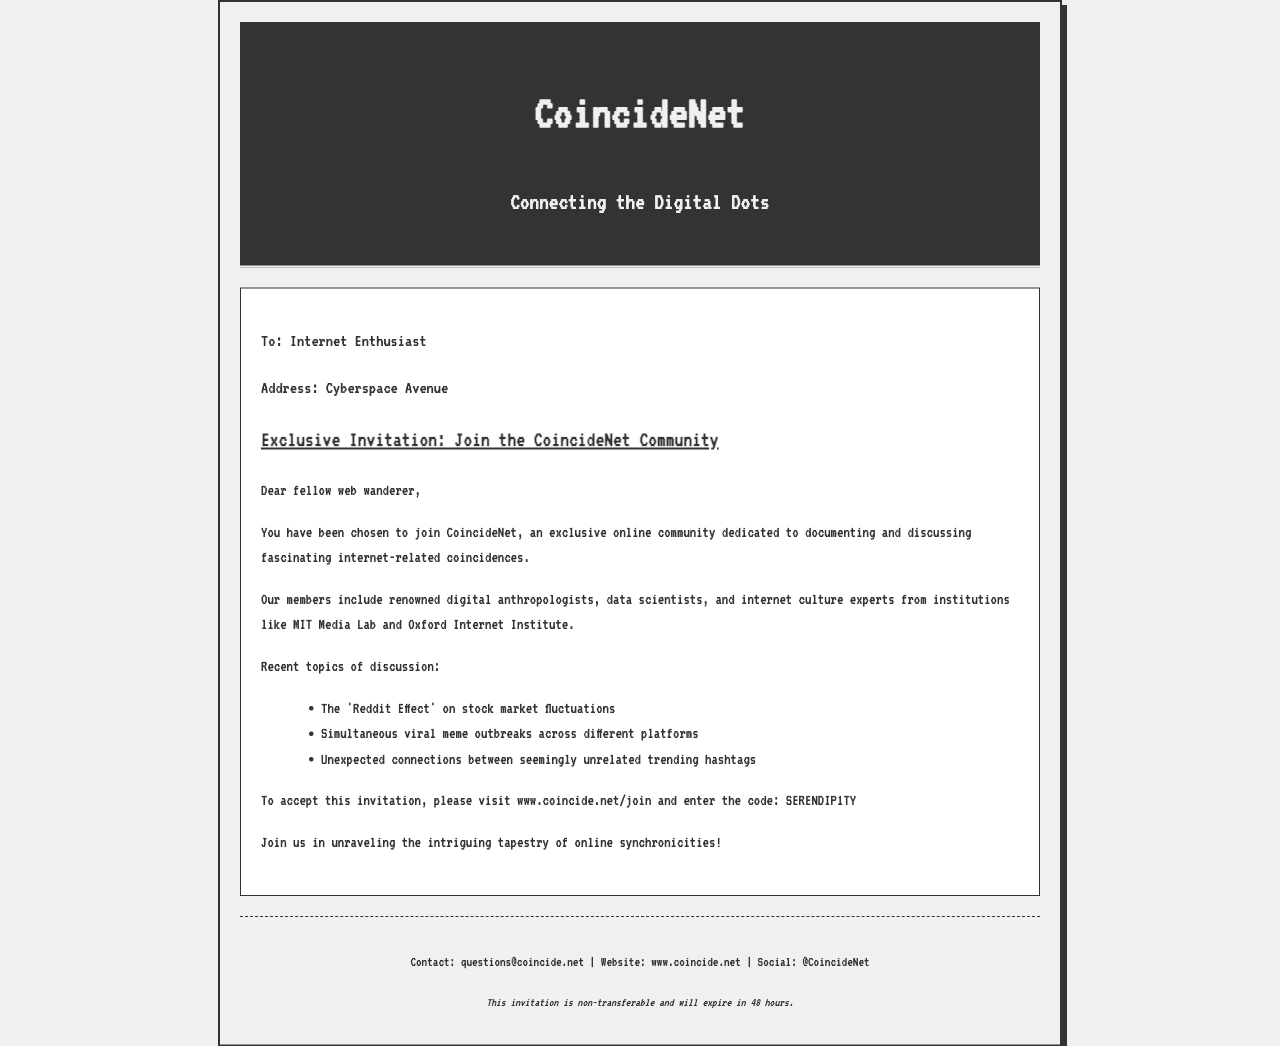What is the name of the community? The community is referred to as CoincideNet in the document.
Answer: CoincideNet Who is the invitation addressed to? The invitation is specifically addressed to an "Internet Enthusiast."
Answer: Internet Enthusiast What is the invitation code? The invitation code provided for joining the community is specified in the body text.
Answer: SERENDIP1TY How long is the invitation valid? The document states that the invitation will expire in a specific timeframe.
Answer: 48 hours What recent topic involves the stock market? The document mentions a topic related to stock market fluctuations.
Answer: The 'Reddit Effect' What institutions are mentioned as members' affiliations? The document lists prominent institutions associated with community members.
Answer: MIT Media Lab and Oxford Internet Institute What are community members interested in documenting? The community focuses on particular phenomena in the digital world.
Answer: Internet-related coincidences What is the website to accept the invitation? The document provides a specific URL for joining the community.
Answer: www.coincide.net/join 